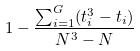Convert formula to latex. <formula><loc_0><loc_0><loc_500><loc_500>1 - \frac { \sum _ { i = 1 } ^ { G } ( t _ { i } ^ { 3 } - t _ { i } ) } { N ^ { 3 } - N }</formula> 